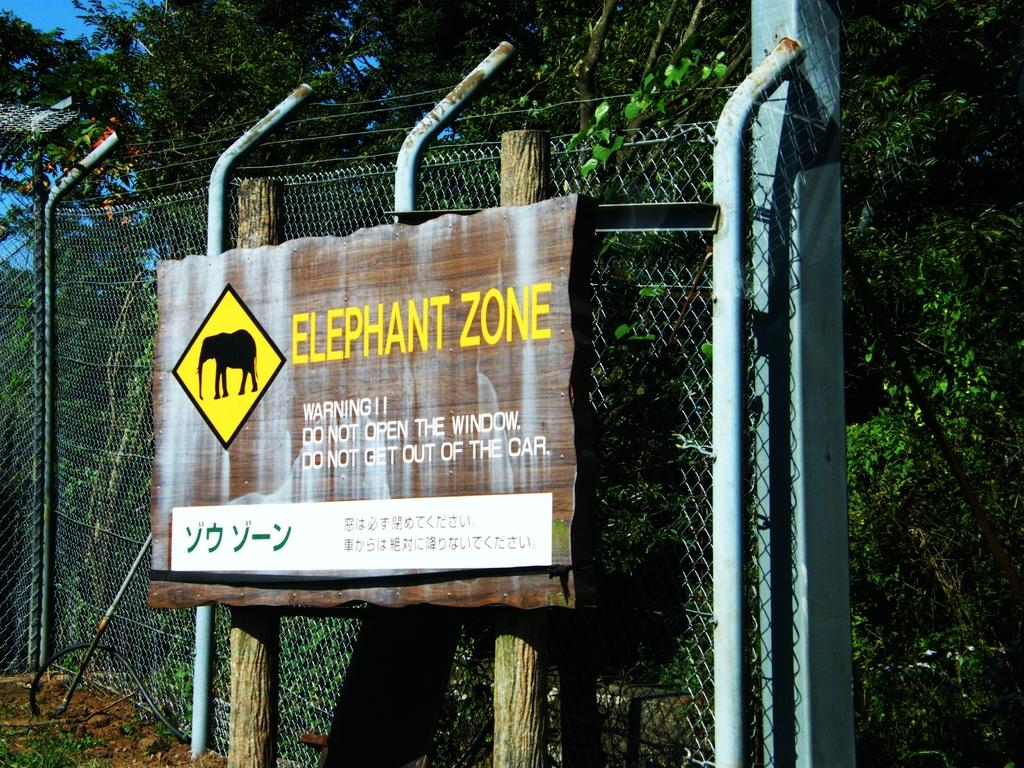What type of barrier can be seen in the image? There is a fence in the image. What is placed in front of the fence? There is a caution board in front of the fence. What can be seen behind the fence? Trees are present behind the fence. What arithmetic problem is being solved on the caution board in the image? There is no arithmetic problem present on the caution board in the image. What type of profit is being discussed on the caution board in the image? There is no mention of profit on the caution board in the image. 